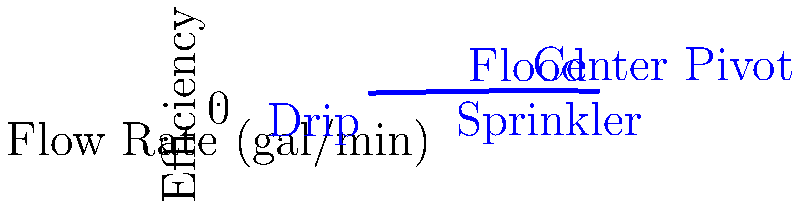Based on the flow rate diagram showing the efficiency of different irrigation systems, which system would be most cost-effective for a large field with varying terrain, considering both water usage and crop yield? To determine the most cost-effective irrigation system for a large field with varying terrain, we need to consider both water usage (flow rate) and efficiency (crop yield). Let's analyze the diagram step-by-step:

1. Drip irrigation:
   - Flow rate: 10 gal/min
   - Efficiency: 75%
   - Best for small areas or row crops, but labor-intensive for large fields

2. Sprinkler irrigation:
   - Flow rate: 15 gal/min
   - Efficiency: 85%
   - Good for medium-sized fields, but may be affected by wind

3. Center Pivot irrigation:
   - Flow rate: 20 gal/min
   - Efficiency: 92%
   - Highest efficiency, suitable for large fields with varying terrain

4. Flood irrigation:
   - Flow rate: 25 gal/min
   - Efficiency: 88%
   - High water usage, not ideal for varying terrain

For a large field with varying terrain, the Center Pivot system offers the best balance between water usage and efficiency. Despite having a higher flow rate than drip and sprinkler systems, its 92% efficiency means less water is wasted. This system can cover large areas efficiently and adapt to different terrains, making it the most cost-effective option in terms of water conservation and crop yield.
Answer: Center Pivot irrigation system 